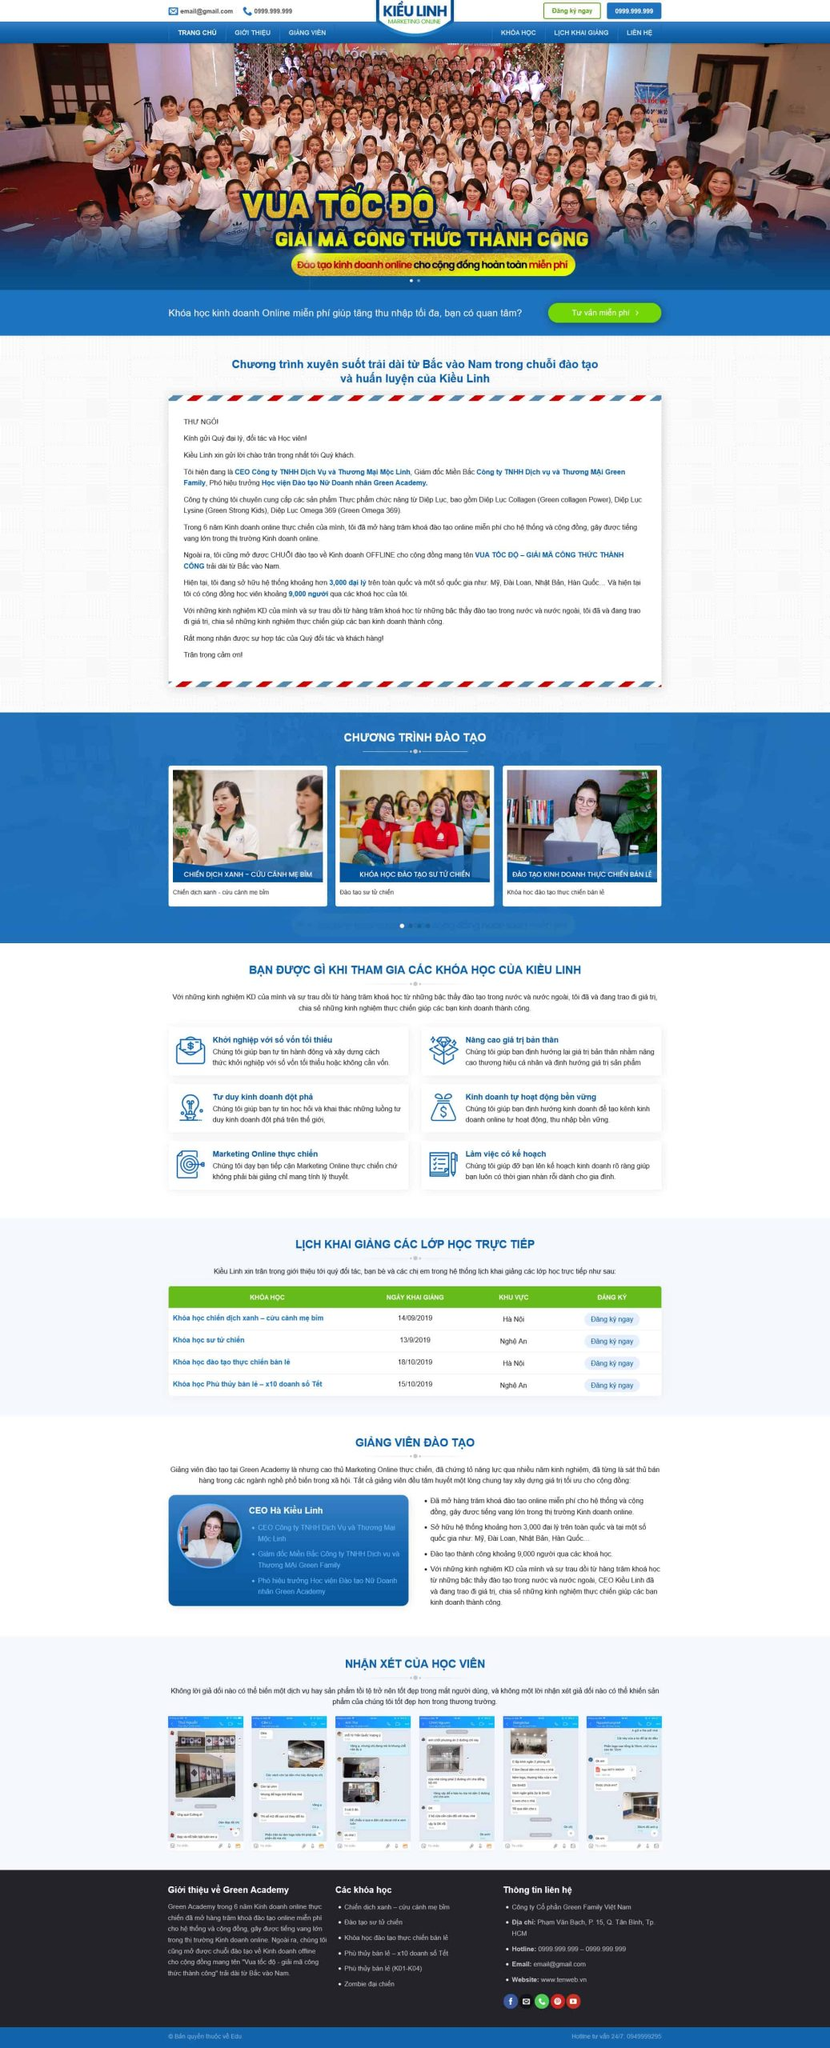Liệt kê 5 ngành nghề, lĩnh vực phù hợp với website này, phân cách các màu sắc bằng dấu phẩy. Chỉ trả về kết quả, phân cách bằng dấy phẩy
 Kinh doanh, Marketing, Dịch vụ khách hàng, Giáo dục, Tư vấn doanh nghiệp 